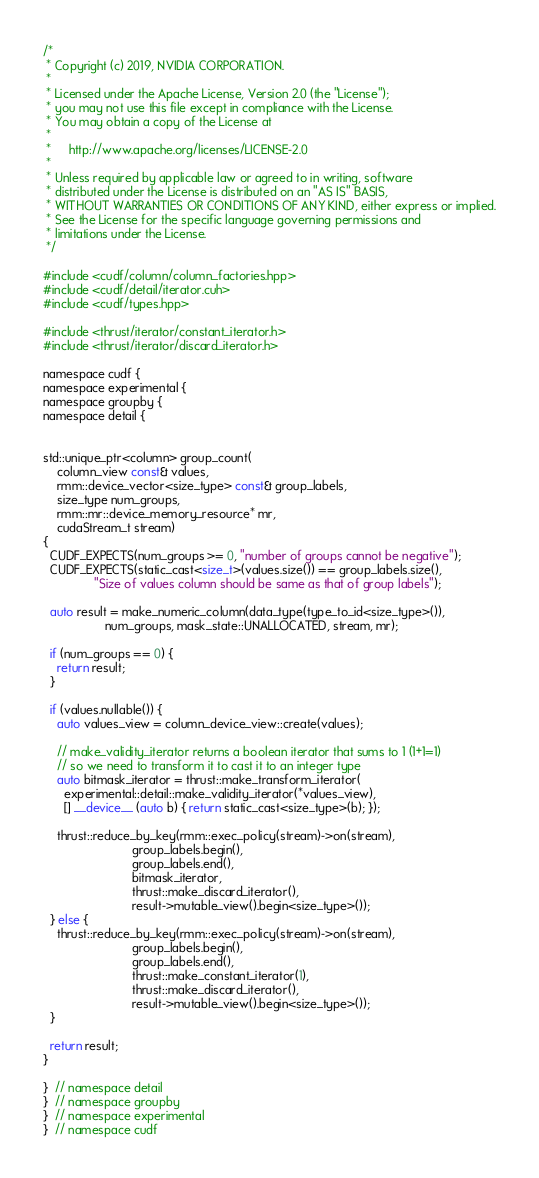Convert code to text. <code><loc_0><loc_0><loc_500><loc_500><_Cuda_>/*
 * Copyright (c) 2019, NVIDIA CORPORATION.
 *
 * Licensed under the Apache License, Version 2.0 (the "License");
 * you may not use this file except in compliance with the License.
 * You may obtain a copy of the License at
 *
 *     http://www.apache.org/licenses/LICENSE-2.0
 *
 * Unless required by applicable law or agreed to in writing, software
 * distributed under the License is distributed on an "AS IS" BASIS,
 * WITHOUT WARRANTIES OR CONDITIONS OF ANY KIND, either express or implied.
 * See the License for the specific language governing permissions and
 * limitations under the License.
 */

#include <cudf/column/column_factories.hpp>
#include <cudf/detail/iterator.cuh>
#include <cudf/types.hpp>

#include <thrust/iterator/constant_iterator.h>
#include <thrust/iterator/discard_iterator.h>

namespace cudf {
namespace experimental {
namespace groupby {
namespace detail {


std::unique_ptr<column> group_count(
    column_view const& values,
    rmm::device_vector<size_type> const& group_labels,
    size_type num_groups,
    rmm::mr::device_memory_resource* mr,
    cudaStream_t stream)
{
  CUDF_EXPECTS(num_groups >= 0, "number of groups cannot be negative");
  CUDF_EXPECTS(static_cast<size_t>(values.size()) == group_labels.size(),
               "Size of values column should be same as that of group labels");

  auto result = make_numeric_column(data_type(type_to_id<size_type>()),
                  num_groups, mask_state::UNALLOCATED, stream, mr);

  if (num_groups == 0) {
    return result;
  }

  if (values.nullable()) {
    auto values_view = column_device_view::create(values);
    
    // make_validity_iterator returns a boolean iterator that sums to 1 (1+1=1)
    // so we need to transform it to cast it to an integer type
    auto bitmask_iterator = thrust::make_transform_iterator(
      experimental::detail::make_validity_iterator(*values_view),
      [] __device__ (auto b) { return static_cast<size_type>(b); });

    thrust::reduce_by_key(rmm::exec_policy(stream)->on(stream),
                          group_labels.begin(),
                          group_labels.end(),
                          bitmask_iterator,
                          thrust::make_discard_iterator(),
                          result->mutable_view().begin<size_type>());
  } else {
    thrust::reduce_by_key(rmm::exec_policy(stream)->on(stream),
                          group_labels.begin(),
                          group_labels.end(),
                          thrust::make_constant_iterator(1),
                          thrust::make_discard_iterator(),
                          result->mutable_view().begin<size_type>());
  }

  return result;
}

}  // namespace detail
}  // namespace groupby
}  // namespace experimental
}  // namespace cudf
</code> 